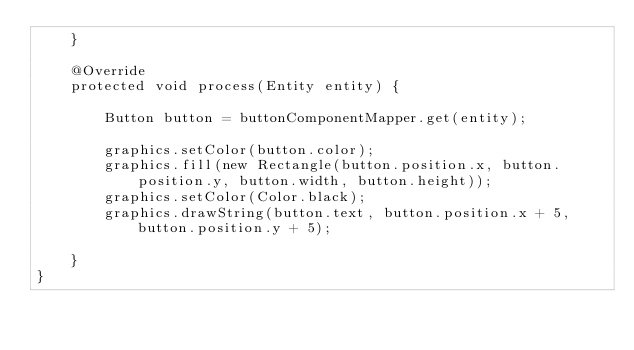Convert code to text. <code><loc_0><loc_0><loc_500><loc_500><_Java_>    }

    @Override
    protected void process(Entity entity) {

        Button button = buttonComponentMapper.get(entity);

        graphics.setColor(button.color);
        graphics.fill(new Rectangle(button.position.x, button.position.y, button.width, button.height));
        graphics.setColor(Color.black);
        graphics.drawString(button.text, button.position.x + 5, button.position.y + 5);

    }
}
</code> 